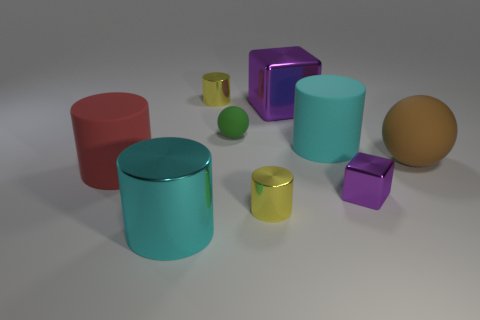Do the matte cylinder that is in front of the big brown matte sphere and the cyan cylinder in front of the brown matte object have the same size?
Your answer should be very brief. Yes. What number of objects are either tiny brown blocks or big rubber cylinders in front of the brown matte sphere?
Ensure brevity in your answer.  1. How big is the rubber ball in front of the small green ball?
Provide a succinct answer. Large. Is the number of tiny purple objects that are right of the brown thing less than the number of tiny metallic blocks that are behind the small rubber thing?
Provide a succinct answer. No. There is a object that is both to the right of the tiny matte sphere and in front of the small purple thing; what is its material?
Your answer should be very brief. Metal. There is a big purple metal object that is in front of the small metallic object behind the large purple object; what shape is it?
Offer a very short reply. Cube. Do the small rubber ball and the big block have the same color?
Offer a terse response. No. How many yellow objects are big shiny things or tiny objects?
Offer a very short reply. 2. Are there any big brown matte balls to the right of the big brown matte ball?
Give a very brief answer. No. What is the size of the cyan rubber object?
Provide a short and direct response. Large. 